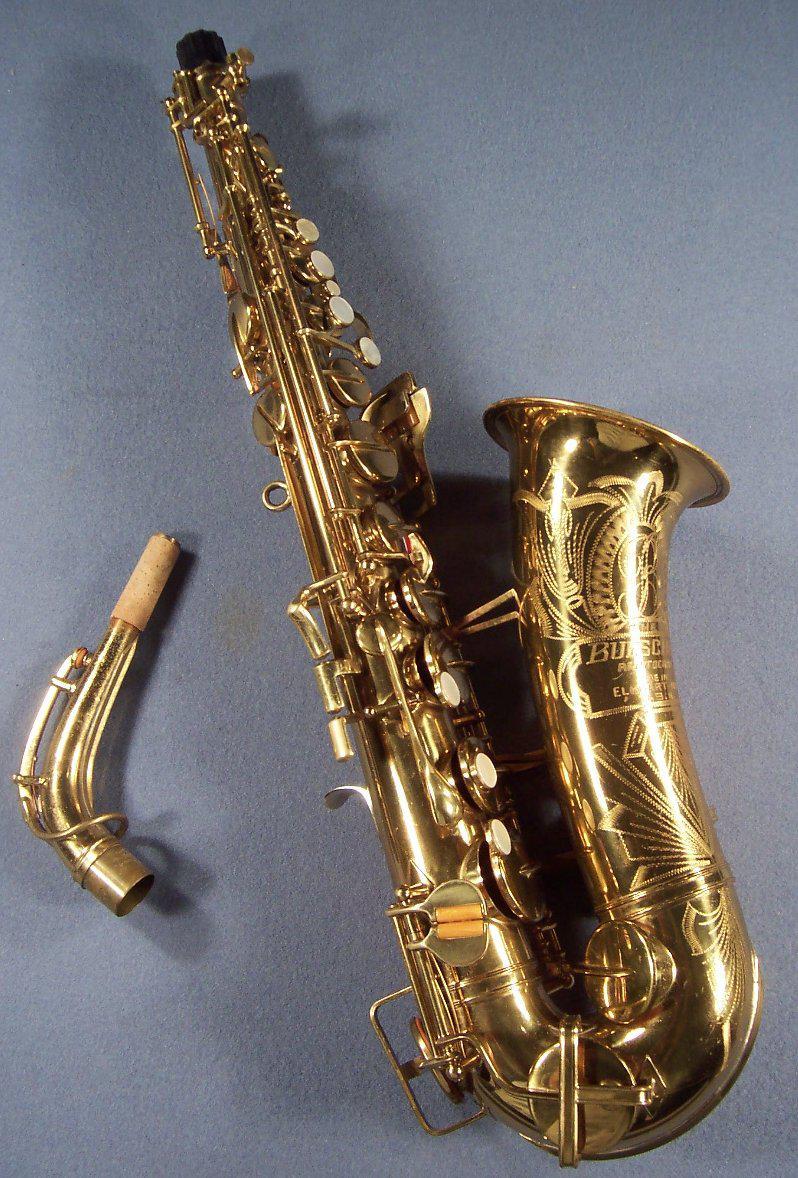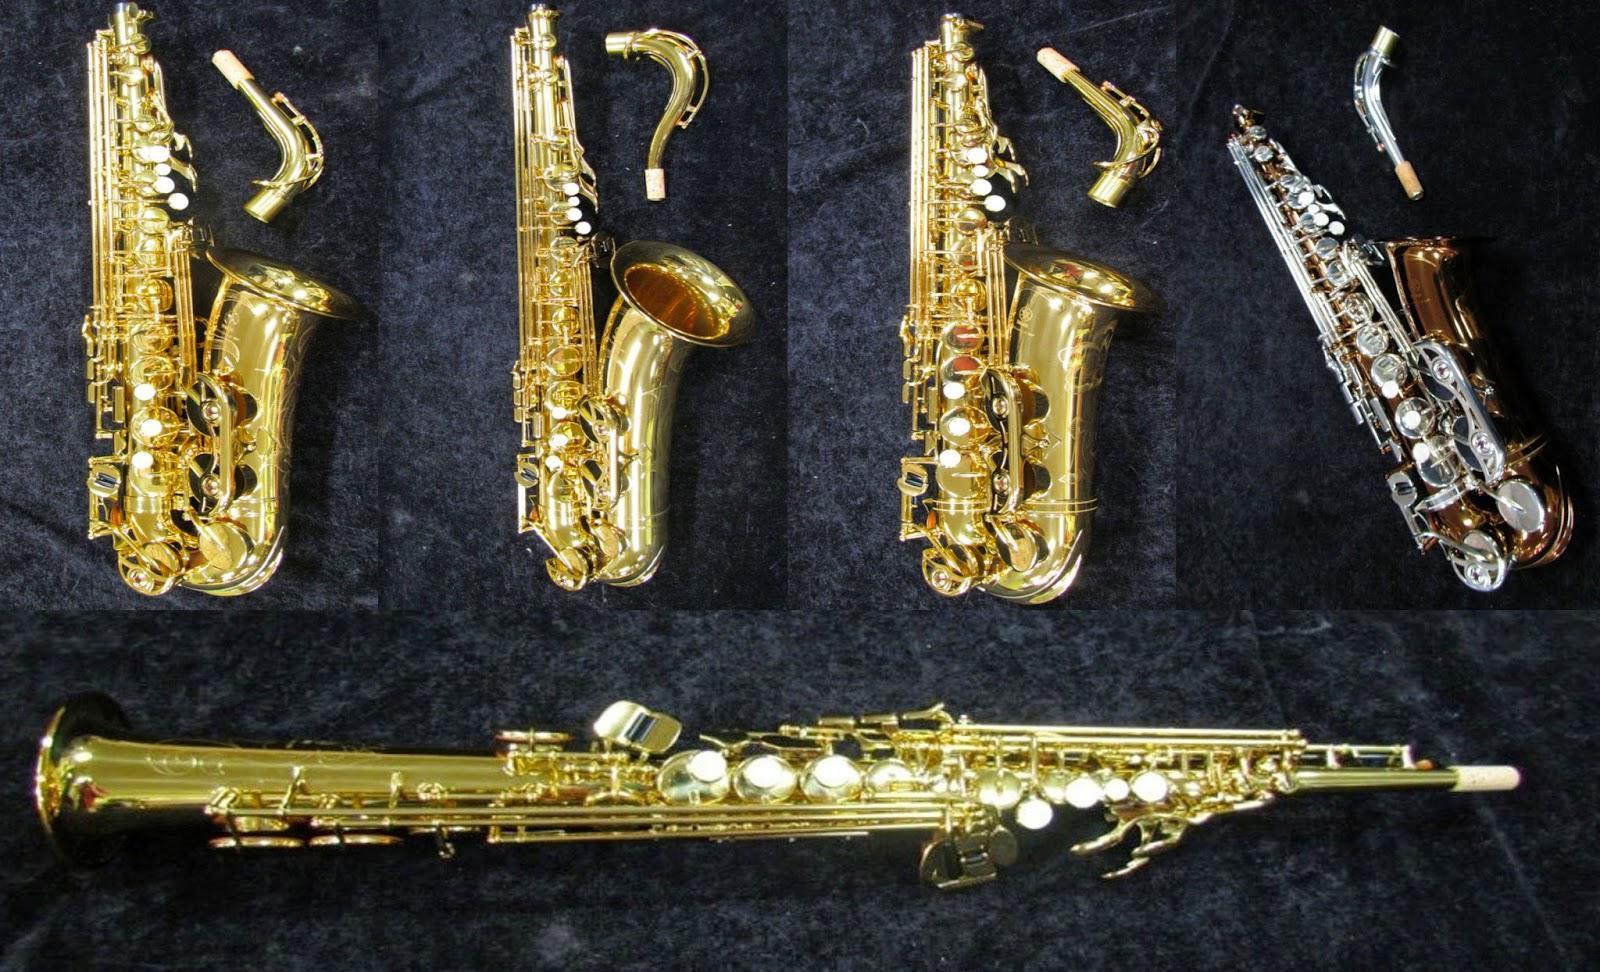The first image is the image on the left, the second image is the image on the right. Examine the images to the left and right. Is the description "There is a single sax in one of the images, and two in the other." accurate? Answer yes or no. No. The first image is the image on the left, the second image is the image on the right. Considering the images on both sides, is "Each saxophone is displayed with its bell facing rightward and its mouthpiece attached, but no saxophone is held by a person." valid? Answer yes or no. No. 